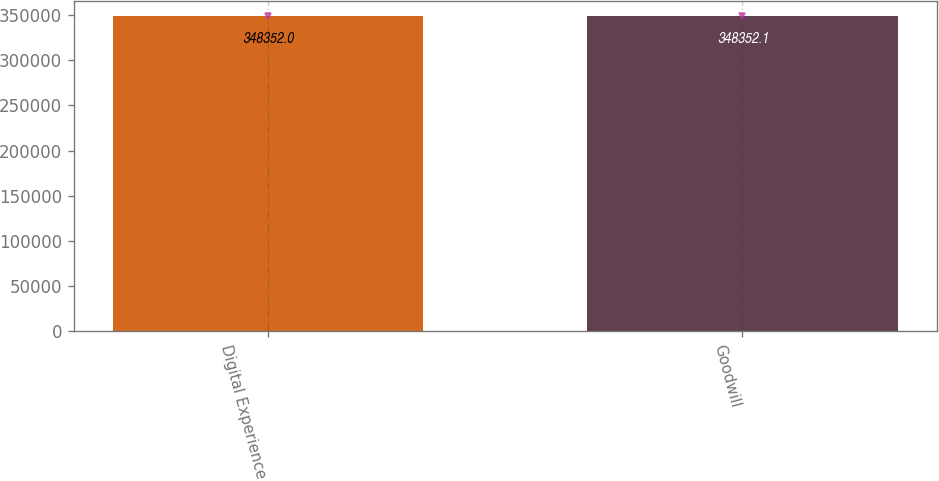Convert chart to OTSL. <chart><loc_0><loc_0><loc_500><loc_500><bar_chart><fcel>Digital Experience<fcel>Goodwill<nl><fcel>348352<fcel>348352<nl></chart> 